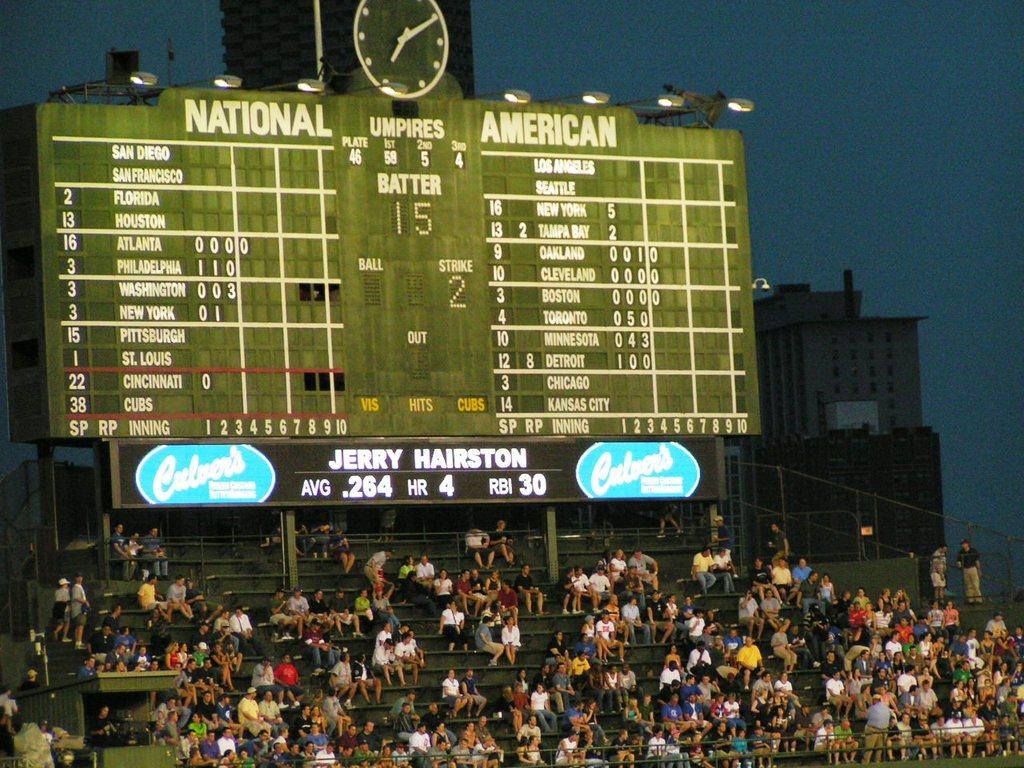Provide a one-sentence caption for the provided image. According to the board player Jerry Hairston is currently up to bat. 